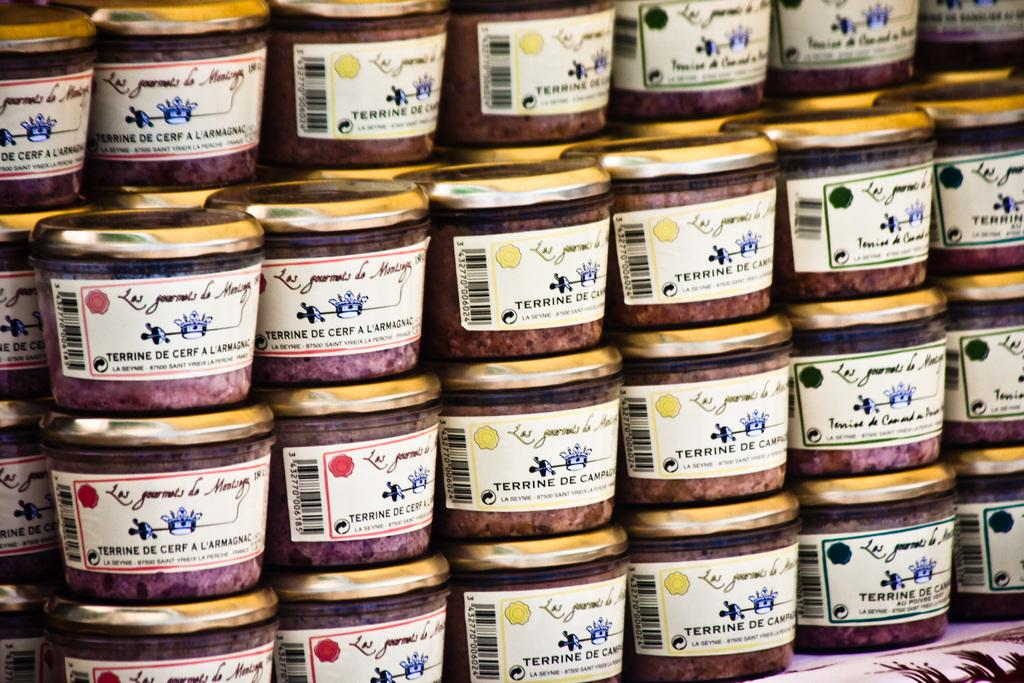Provide a one-sentence caption for the provided image. A series of Terrine De Cerf A Larmagnac jars stacked on top of each other. 